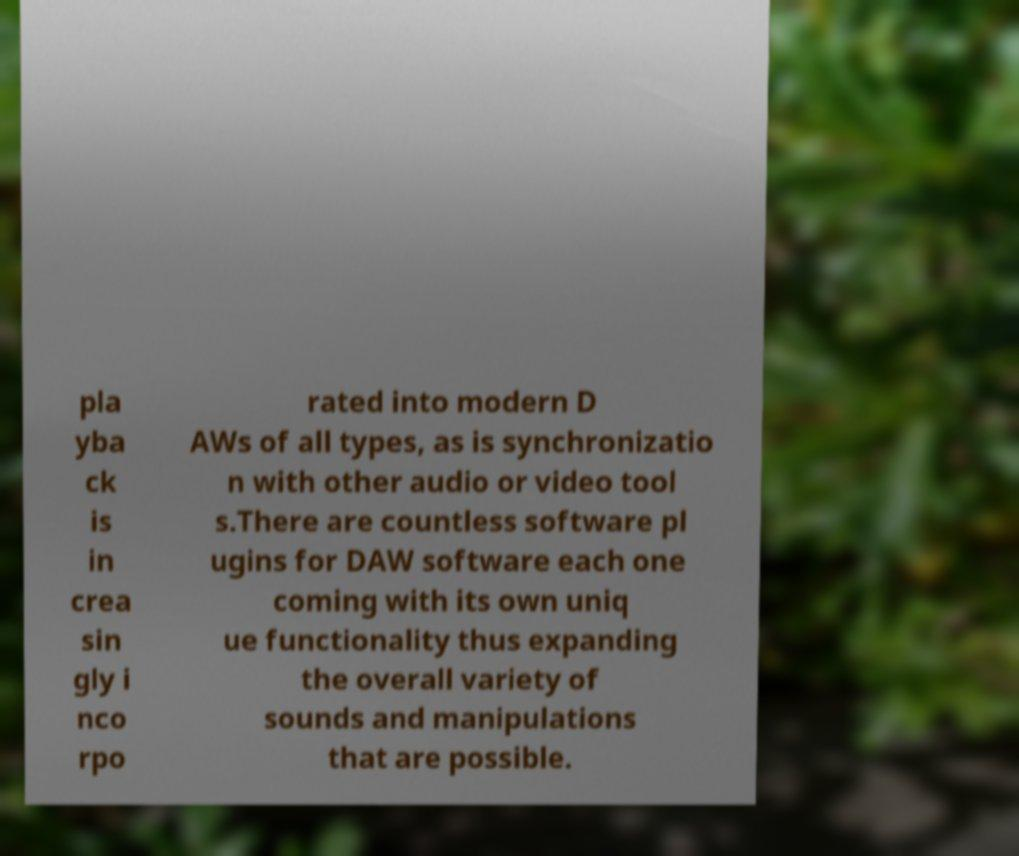Can you accurately transcribe the text from the provided image for me? pla yba ck is in crea sin gly i nco rpo rated into modern D AWs of all types, as is synchronizatio n with other audio or video tool s.There are countless software pl ugins for DAW software each one coming with its own uniq ue functionality thus expanding the overall variety of sounds and manipulations that are possible. 